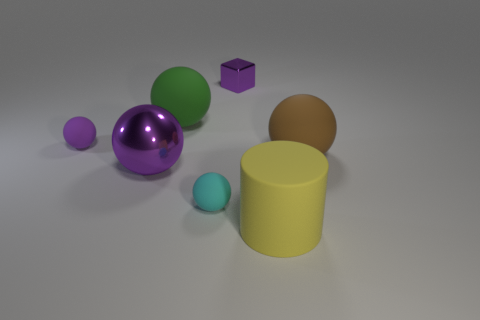Subtract all green balls. How many balls are left? 4 Subtract all gray balls. Subtract all brown blocks. How many balls are left? 5 Add 2 tiny purple rubber objects. How many objects exist? 9 Subtract all cylinders. How many objects are left? 6 Add 1 purple metallic blocks. How many purple metallic blocks are left? 2 Add 3 purple blocks. How many purple blocks exist? 4 Subtract 0 green cylinders. How many objects are left? 7 Subtract all blue matte cylinders. Subtract all cyan rubber balls. How many objects are left? 6 